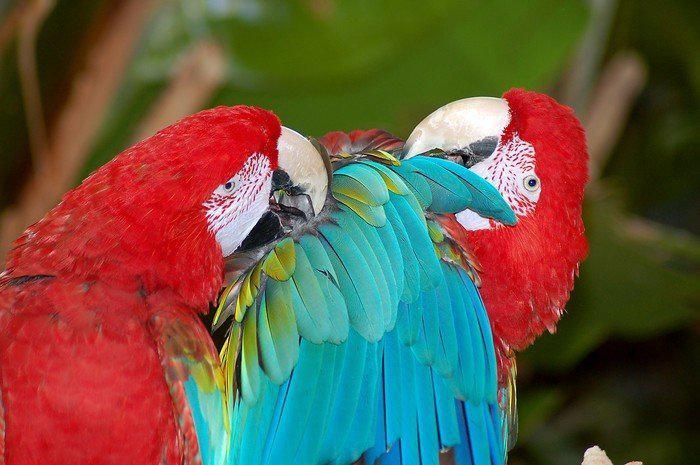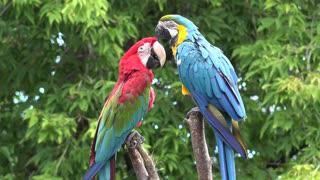The first image is the image on the left, the second image is the image on the right. Considering the images on both sides, is "One image shows two solid-blue parrots perched on a branch, and the other image shows one red-headed bird next to a blue-and-yellow bird." valid? Answer yes or no. No. The first image is the image on the left, the second image is the image on the right. Evaluate the accuracy of this statement regarding the images: "There are two blue birds perching on the same branch in one of the images.". Is it true? Answer yes or no. No. 